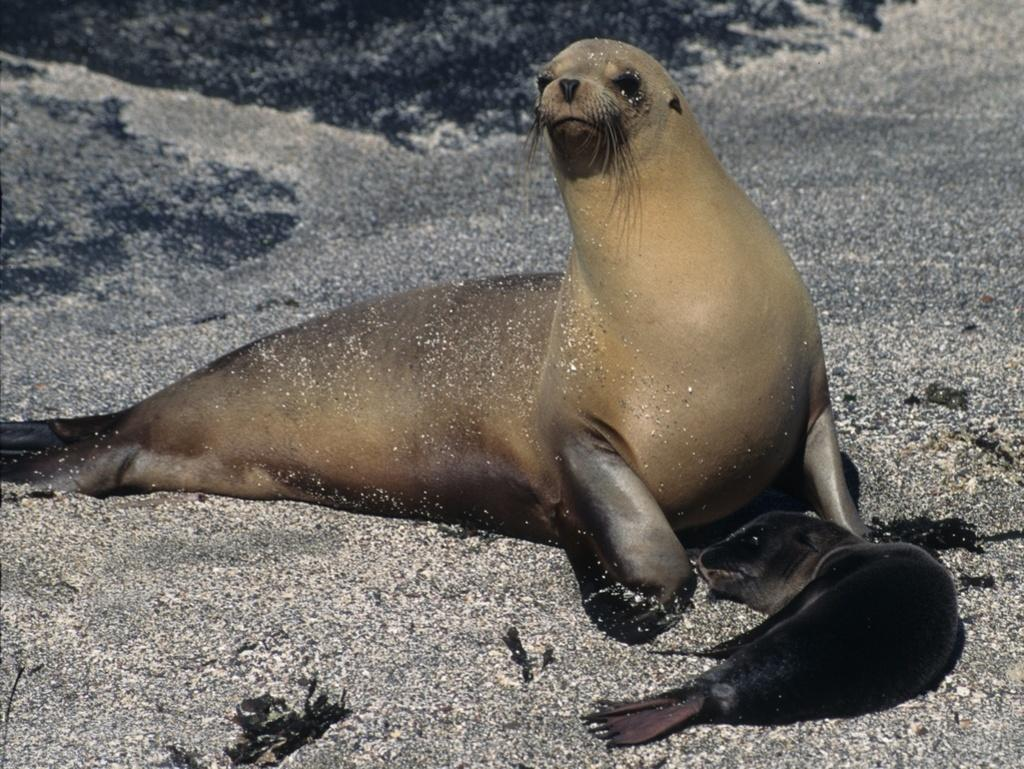What types of living organisms can be seen in the image? There are animals in the image. Where are the animals located? The animals are on the sand. What type of sheep can be seen grazing near the flame in the image? There is no sheep or flame present in the image; it only features animals on the sand. What sound do the bells make in the image? There are no bells present in the image. 